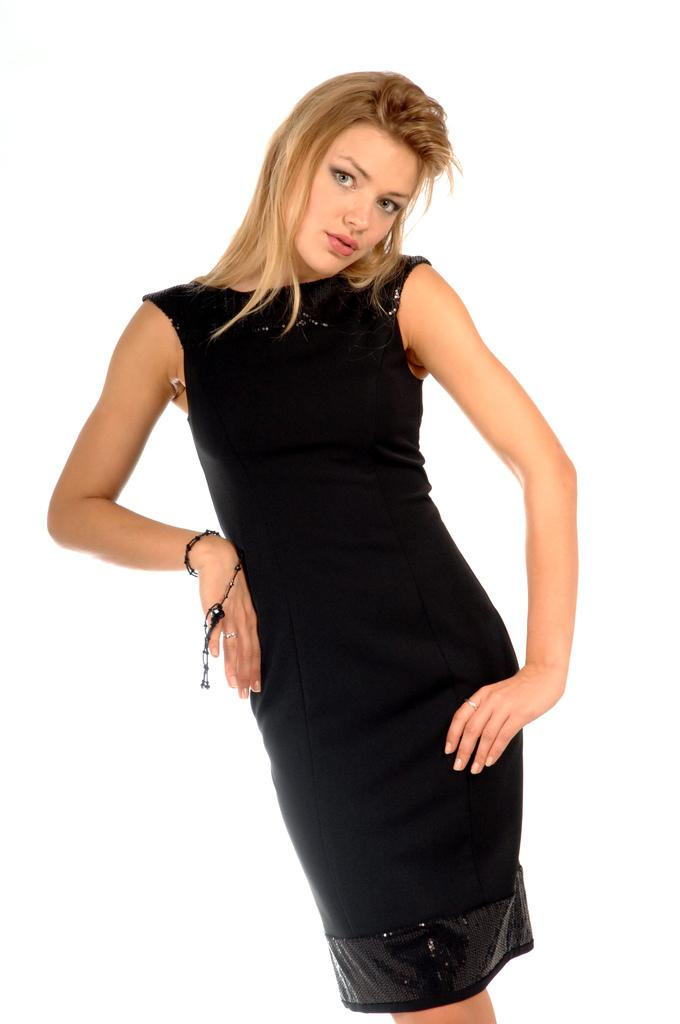Who is present in the image? There is a woman in the picture. What is the woman wearing? The woman is wearing a black dress. What is the woman doing in the image? The woman is standing. What type of coach can be seen in the background of the image? There is no coach present in the background of the image. Is there a sink visible in the image? There is no sink visible in the image. 